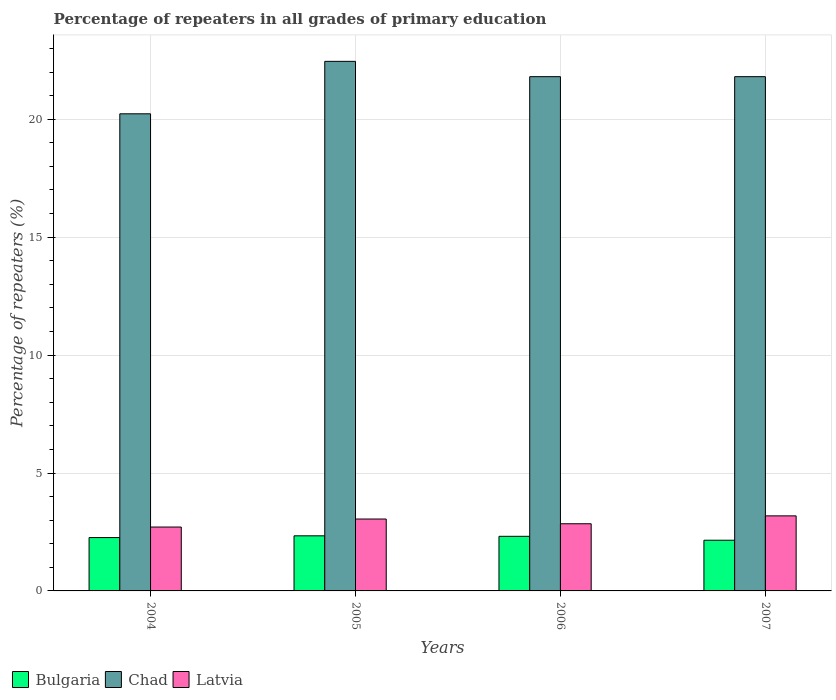How many different coloured bars are there?
Make the answer very short. 3. Are the number of bars per tick equal to the number of legend labels?
Your answer should be very brief. Yes. Are the number of bars on each tick of the X-axis equal?
Offer a terse response. Yes. How many bars are there on the 2nd tick from the left?
Offer a terse response. 3. What is the label of the 3rd group of bars from the left?
Your answer should be very brief. 2006. In how many cases, is the number of bars for a given year not equal to the number of legend labels?
Provide a short and direct response. 0. What is the percentage of repeaters in Latvia in 2006?
Your response must be concise. 2.85. Across all years, what is the maximum percentage of repeaters in Latvia?
Offer a terse response. 3.18. Across all years, what is the minimum percentage of repeaters in Latvia?
Provide a succinct answer. 2.71. In which year was the percentage of repeaters in Latvia maximum?
Your response must be concise. 2007. In which year was the percentage of repeaters in Chad minimum?
Offer a terse response. 2004. What is the total percentage of repeaters in Latvia in the graph?
Your answer should be very brief. 11.79. What is the difference between the percentage of repeaters in Latvia in 2005 and that in 2006?
Your answer should be compact. 0.2. What is the difference between the percentage of repeaters in Latvia in 2005 and the percentage of repeaters in Bulgaria in 2004?
Give a very brief answer. 0.79. What is the average percentage of repeaters in Bulgaria per year?
Give a very brief answer. 2.27. In the year 2004, what is the difference between the percentage of repeaters in Chad and percentage of repeaters in Bulgaria?
Ensure brevity in your answer.  17.97. What is the ratio of the percentage of repeaters in Bulgaria in 2006 to that in 2007?
Offer a very short reply. 1.08. What is the difference between the highest and the second highest percentage of repeaters in Chad?
Keep it short and to the point. 0.65. What is the difference between the highest and the lowest percentage of repeaters in Bulgaria?
Your response must be concise. 0.19. Is the sum of the percentage of repeaters in Chad in 2005 and 2007 greater than the maximum percentage of repeaters in Bulgaria across all years?
Provide a succinct answer. Yes. What does the 3rd bar from the left in 2004 represents?
Give a very brief answer. Latvia. What does the 1st bar from the right in 2006 represents?
Provide a short and direct response. Latvia. How many bars are there?
Offer a terse response. 12. Does the graph contain any zero values?
Your response must be concise. No. What is the title of the graph?
Ensure brevity in your answer.  Percentage of repeaters in all grades of primary education. What is the label or title of the Y-axis?
Ensure brevity in your answer.  Percentage of repeaters (%). What is the Percentage of repeaters (%) of Bulgaria in 2004?
Your response must be concise. 2.26. What is the Percentage of repeaters (%) of Chad in 2004?
Your answer should be compact. 20.23. What is the Percentage of repeaters (%) in Latvia in 2004?
Your response must be concise. 2.71. What is the Percentage of repeaters (%) in Bulgaria in 2005?
Provide a succinct answer. 2.34. What is the Percentage of repeaters (%) of Chad in 2005?
Keep it short and to the point. 22.45. What is the Percentage of repeaters (%) in Latvia in 2005?
Give a very brief answer. 3.05. What is the Percentage of repeaters (%) of Bulgaria in 2006?
Your response must be concise. 2.32. What is the Percentage of repeaters (%) of Chad in 2006?
Your response must be concise. 21.81. What is the Percentage of repeaters (%) in Latvia in 2006?
Give a very brief answer. 2.85. What is the Percentage of repeaters (%) of Bulgaria in 2007?
Provide a succinct answer. 2.15. What is the Percentage of repeaters (%) of Chad in 2007?
Your response must be concise. 21.8. What is the Percentage of repeaters (%) in Latvia in 2007?
Your response must be concise. 3.18. Across all years, what is the maximum Percentage of repeaters (%) in Bulgaria?
Your answer should be compact. 2.34. Across all years, what is the maximum Percentage of repeaters (%) of Chad?
Your response must be concise. 22.45. Across all years, what is the maximum Percentage of repeaters (%) in Latvia?
Give a very brief answer. 3.18. Across all years, what is the minimum Percentage of repeaters (%) of Bulgaria?
Offer a very short reply. 2.15. Across all years, what is the minimum Percentage of repeaters (%) in Chad?
Offer a terse response. 20.23. Across all years, what is the minimum Percentage of repeaters (%) of Latvia?
Provide a short and direct response. 2.71. What is the total Percentage of repeaters (%) of Bulgaria in the graph?
Offer a very short reply. 9.06. What is the total Percentage of repeaters (%) of Chad in the graph?
Make the answer very short. 86.29. What is the total Percentage of repeaters (%) in Latvia in the graph?
Give a very brief answer. 11.79. What is the difference between the Percentage of repeaters (%) in Bulgaria in 2004 and that in 2005?
Your answer should be compact. -0.07. What is the difference between the Percentage of repeaters (%) in Chad in 2004 and that in 2005?
Offer a very short reply. -2.22. What is the difference between the Percentage of repeaters (%) in Latvia in 2004 and that in 2005?
Your answer should be very brief. -0.34. What is the difference between the Percentage of repeaters (%) of Bulgaria in 2004 and that in 2006?
Your response must be concise. -0.05. What is the difference between the Percentage of repeaters (%) in Chad in 2004 and that in 2006?
Provide a succinct answer. -1.57. What is the difference between the Percentage of repeaters (%) in Latvia in 2004 and that in 2006?
Offer a terse response. -0.14. What is the difference between the Percentage of repeaters (%) in Bulgaria in 2004 and that in 2007?
Ensure brevity in your answer.  0.11. What is the difference between the Percentage of repeaters (%) of Chad in 2004 and that in 2007?
Provide a short and direct response. -1.57. What is the difference between the Percentage of repeaters (%) of Latvia in 2004 and that in 2007?
Your answer should be very brief. -0.47. What is the difference between the Percentage of repeaters (%) of Bulgaria in 2005 and that in 2006?
Give a very brief answer. 0.02. What is the difference between the Percentage of repeaters (%) in Chad in 2005 and that in 2006?
Make the answer very short. 0.65. What is the difference between the Percentage of repeaters (%) in Latvia in 2005 and that in 2006?
Keep it short and to the point. 0.2. What is the difference between the Percentage of repeaters (%) in Bulgaria in 2005 and that in 2007?
Make the answer very short. 0.19. What is the difference between the Percentage of repeaters (%) of Chad in 2005 and that in 2007?
Give a very brief answer. 0.65. What is the difference between the Percentage of repeaters (%) of Latvia in 2005 and that in 2007?
Ensure brevity in your answer.  -0.13. What is the difference between the Percentage of repeaters (%) in Bulgaria in 2006 and that in 2007?
Your response must be concise. 0.17. What is the difference between the Percentage of repeaters (%) in Chad in 2006 and that in 2007?
Provide a succinct answer. 0. What is the difference between the Percentage of repeaters (%) in Latvia in 2006 and that in 2007?
Your response must be concise. -0.33. What is the difference between the Percentage of repeaters (%) in Bulgaria in 2004 and the Percentage of repeaters (%) in Chad in 2005?
Your response must be concise. -20.19. What is the difference between the Percentage of repeaters (%) of Bulgaria in 2004 and the Percentage of repeaters (%) of Latvia in 2005?
Make the answer very short. -0.79. What is the difference between the Percentage of repeaters (%) in Chad in 2004 and the Percentage of repeaters (%) in Latvia in 2005?
Make the answer very short. 17.18. What is the difference between the Percentage of repeaters (%) in Bulgaria in 2004 and the Percentage of repeaters (%) in Chad in 2006?
Offer a terse response. -19.54. What is the difference between the Percentage of repeaters (%) of Bulgaria in 2004 and the Percentage of repeaters (%) of Latvia in 2006?
Provide a short and direct response. -0.59. What is the difference between the Percentage of repeaters (%) of Chad in 2004 and the Percentage of repeaters (%) of Latvia in 2006?
Offer a terse response. 17.38. What is the difference between the Percentage of repeaters (%) of Bulgaria in 2004 and the Percentage of repeaters (%) of Chad in 2007?
Give a very brief answer. -19.54. What is the difference between the Percentage of repeaters (%) in Bulgaria in 2004 and the Percentage of repeaters (%) in Latvia in 2007?
Ensure brevity in your answer.  -0.92. What is the difference between the Percentage of repeaters (%) of Chad in 2004 and the Percentage of repeaters (%) of Latvia in 2007?
Provide a short and direct response. 17.05. What is the difference between the Percentage of repeaters (%) of Bulgaria in 2005 and the Percentage of repeaters (%) of Chad in 2006?
Give a very brief answer. -19.47. What is the difference between the Percentage of repeaters (%) of Bulgaria in 2005 and the Percentage of repeaters (%) of Latvia in 2006?
Offer a very short reply. -0.51. What is the difference between the Percentage of repeaters (%) of Chad in 2005 and the Percentage of repeaters (%) of Latvia in 2006?
Offer a terse response. 19.61. What is the difference between the Percentage of repeaters (%) in Bulgaria in 2005 and the Percentage of repeaters (%) in Chad in 2007?
Offer a very short reply. -19.47. What is the difference between the Percentage of repeaters (%) in Bulgaria in 2005 and the Percentage of repeaters (%) in Latvia in 2007?
Your answer should be compact. -0.85. What is the difference between the Percentage of repeaters (%) in Chad in 2005 and the Percentage of repeaters (%) in Latvia in 2007?
Give a very brief answer. 19.27. What is the difference between the Percentage of repeaters (%) in Bulgaria in 2006 and the Percentage of repeaters (%) in Chad in 2007?
Keep it short and to the point. -19.49. What is the difference between the Percentage of repeaters (%) of Bulgaria in 2006 and the Percentage of repeaters (%) of Latvia in 2007?
Provide a short and direct response. -0.87. What is the difference between the Percentage of repeaters (%) of Chad in 2006 and the Percentage of repeaters (%) of Latvia in 2007?
Your answer should be very brief. 18.62. What is the average Percentage of repeaters (%) of Bulgaria per year?
Your answer should be very brief. 2.27. What is the average Percentage of repeaters (%) in Chad per year?
Your answer should be very brief. 21.57. What is the average Percentage of repeaters (%) of Latvia per year?
Your response must be concise. 2.95. In the year 2004, what is the difference between the Percentage of repeaters (%) of Bulgaria and Percentage of repeaters (%) of Chad?
Keep it short and to the point. -17.97. In the year 2004, what is the difference between the Percentage of repeaters (%) of Bulgaria and Percentage of repeaters (%) of Latvia?
Give a very brief answer. -0.45. In the year 2004, what is the difference between the Percentage of repeaters (%) of Chad and Percentage of repeaters (%) of Latvia?
Your response must be concise. 17.52. In the year 2005, what is the difference between the Percentage of repeaters (%) in Bulgaria and Percentage of repeaters (%) in Chad?
Keep it short and to the point. -20.12. In the year 2005, what is the difference between the Percentage of repeaters (%) in Bulgaria and Percentage of repeaters (%) in Latvia?
Offer a very short reply. -0.71. In the year 2005, what is the difference between the Percentage of repeaters (%) of Chad and Percentage of repeaters (%) of Latvia?
Provide a succinct answer. 19.41. In the year 2006, what is the difference between the Percentage of repeaters (%) in Bulgaria and Percentage of repeaters (%) in Chad?
Your answer should be very brief. -19.49. In the year 2006, what is the difference between the Percentage of repeaters (%) in Bulgaria and Percentage of repeaters (%) in Latvia?
Your response must be concise. -0.53. In the year 2006, what is the difference between the Percentage of repeaters (%) of Chad and Percentage of repeaters (%) of Latvia?
Provide a succinct answer. 18.96. In the year 2007, what is the difference between the Percentage of repeaters (%) of Bulgaria and Percentage of repeaters (%) of Chad?
Provide a short and direct response. -19.66. In the year 2007, what is the difference between the Percentage of repeaters (%) of Bulgaria and Percentage of repeaters (%) of Latvia?
Your answer should be compact. -1.03. In the year 2007, what is the difference between the Percentage of repeaters (%) of Chad and Percentage of repeaters (%) of Latvia?
Keep it short and to the point. 18.62. What is the ratio of the Percentage of repeaters (%) of Bulgaria in 2004 to that in 2005?
Offer a terse response. 0.97. What is the ratio of the Percentage of repeaters (%) of Chad in 2004 to that in 2005?
Make the answer very short. 0.9. What is the ratio of the Percentage of repeaters (%) of Latvia in 2004 to that in 2005?
Give a very brief answer. 0.89. What is the ratio of the Percentage of repeaters (%) in Bulgaria in 2004 to that in 2006?
Offer a terse response. 0.98. What is the ratio of the Percentage of repeaters (%) of Chad in 2004 to that in 2006?
Make the answer very short. 0.93. What is the ratio of the Percentage of repeaters (%) of Latvia in 2004 to that in 2006?
Your answer should be very brief. 0.95. What is the ratio of the Percentage of repeaters (%) of Bulgaria in 2004 to that in 2007?
Give a very brief answer. 1.05. What is the ratio of the Percentage of repeaters (%) in Chad in 2004 to that in 2007?
Make the answer very short. 0.93. What is the ratio of the Percentage of repeaters (%) of Latvia in 2004 to that in 2007?
Keep it short and to the point. 0.85. What is the ratio of the Percentage of repeaters (%) of Bulgaria in 2005 to that in 2006?
Provide a short and direct response. 1.01. What is the ratio of the Percentage of repeaters (%) in Chad in 2005 to that in 2006?
Provide a succinct answer. 1.03. What is the ratio of the Percentage of repeaters (%) of Latvia in 2005 to that in 2006?
Make the answer very short. 1.07. What is the ratio of the Percentage of repeaters (%) of Bulgaria in 2005 to that in 2007?
Provide a succinct answer. 1.09. What is the ratio of the Percentage of repeaters (%) of Chad in 2005 to that in 2007?
Your answer should be very brief. 1.03. What is the ratio of the Percentage of repeaters (%) of Latvia in 2005 to that in 2007?
Your response must be concise. 0.96. What is the ratio of the Percentage of repeaters (%) in Bulgaria in 2006 to that in 2007?
Provide a succinct answer. 1.08. What is the ratio of the Percentage of repeaters (%) of Chad in 2006 to that in 2007?
Your response must be concise. 1. What is the ratio of the Percentage of repeaters (%) in Latvia in 2006 to that in 2007?
Provide a succinct answer. 0.89. What is the difference between the highest and the second highest Percentage of repeaters (%) in Bulgaria?
Offer a very short reply. 0.02. What is the difference between the highest and the second highest Percentage of repeaters (%) in Chad?
Give a very brief answer. 0.65. What is the difference between the highest and the second highest Percentage of repeaters (%) in Latvia?
Provide a succinct answer. 0.13. What is the difference between the highest and the lowest Percentage of repeaters (%) of Bulgaria?
Provide a succinct answer. 0.19. What is the difference between the highest and the lowest Percentage of repeaters (%) in Chad?
Your response must be concise. 2.22. What is the difference between the highest and the lowest Percentage of repeaters (%) in Latvia?
Your response must be concise. 0.47. 